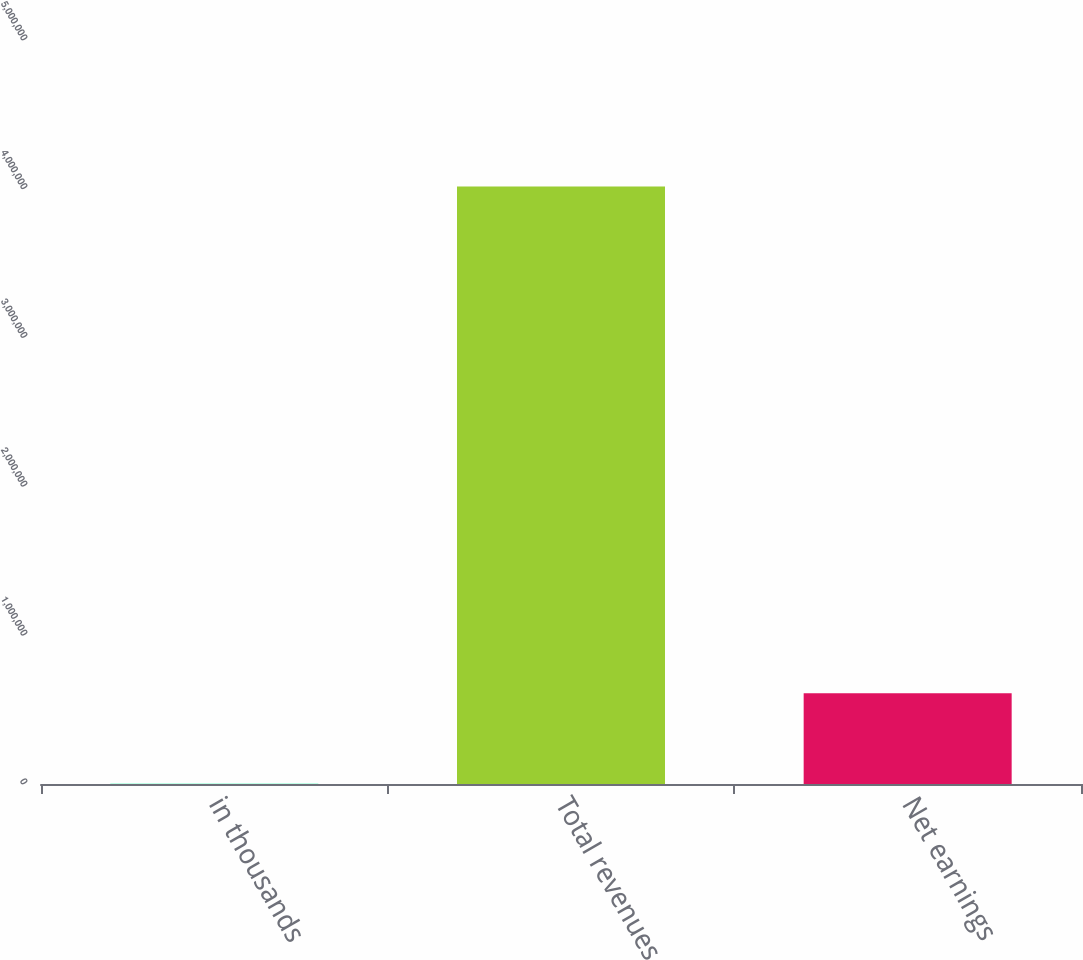<chart> <loc_0><loc_0><loc_500><loc_500><bar_chart><fcel>in thousands<fcel>Total revenues<fcel>Net earnings<nl><fcel>2017<fcel>4.01589e+06<fcel>610494<nl></chart> 